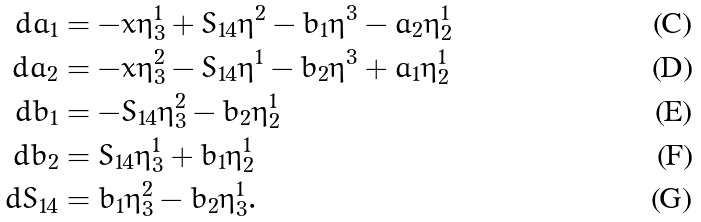<formula> <loc_0><loc_0><loc_500><loc_500>d a _ { 1 } & = - x \eta ^ { 1 } _ { 3 } + S _ { 1 4 } \eta ^ { 2 } - b _ { 1 } \eta ^ { 3 } - a _ { 2 } \eta ^ { 1 } _ { 2 } \\ d a _ { 2 } & = - x \eta ^ { 2 } _ { 3 } - S _ { 1 4 } \eta ^ { 1 } - b _ { 2 } \eta ^ { 3 } + a _ { 1 } \eta ^ { 1 } _ { 2 } \\ d b _ { 1 } & = - S _ { 1 4 } \eta ^ { 2 } _ { 3 } - b _ { 2 } \eta ^ { 1 } _ { 2 } \\ d b _ { 2 } & = S _ { 1 4 } \eta ^ { 1 } _ { 3 } + b _ { 1 } \eta ^ { 1 } _ { 2 } \\ d S _ { 1 4 } & = b _ { 1 } \eta ^ { 2 } _ { 3 } - b _ { 2 } \eta ^ { 1 } _ { 3 } .</formula> 